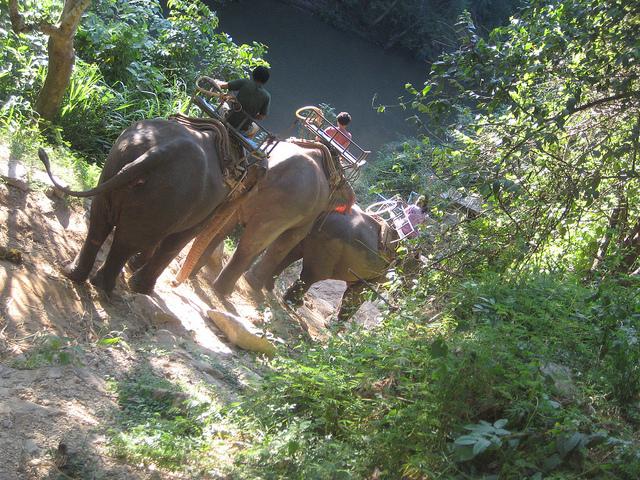How many elephants are visible?
Give a very brief answer. 3. Are these elephants looking for a computer so they can go on the internet?
Short answer required. No. Do these animals travel in herds?
Answer briefly. Yes. 